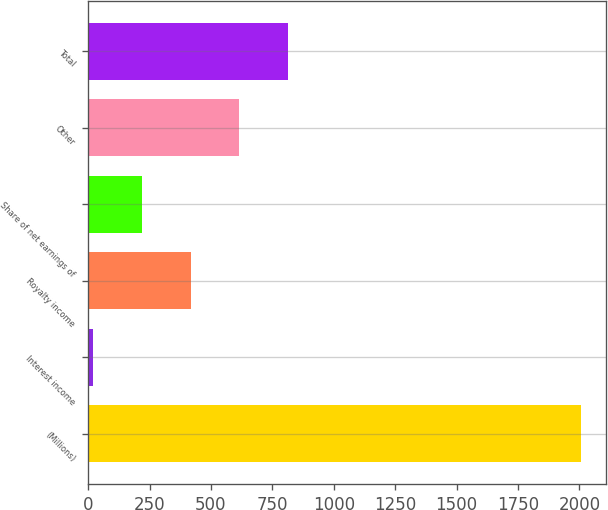Convert chart. <chart><loc_0><loc_0><loc_500><loc_500><bar_chart><fcel>(Millions)<fcel>Interest income<fcel>Royalty income<fcel>Share of net earnings of<fcel>Other<fcel>Total<nl><fcel>2007<fcel>20<fcel>417.4<fcel>218.7<fcel>616.1<fcel>814.8<nl></chart> 